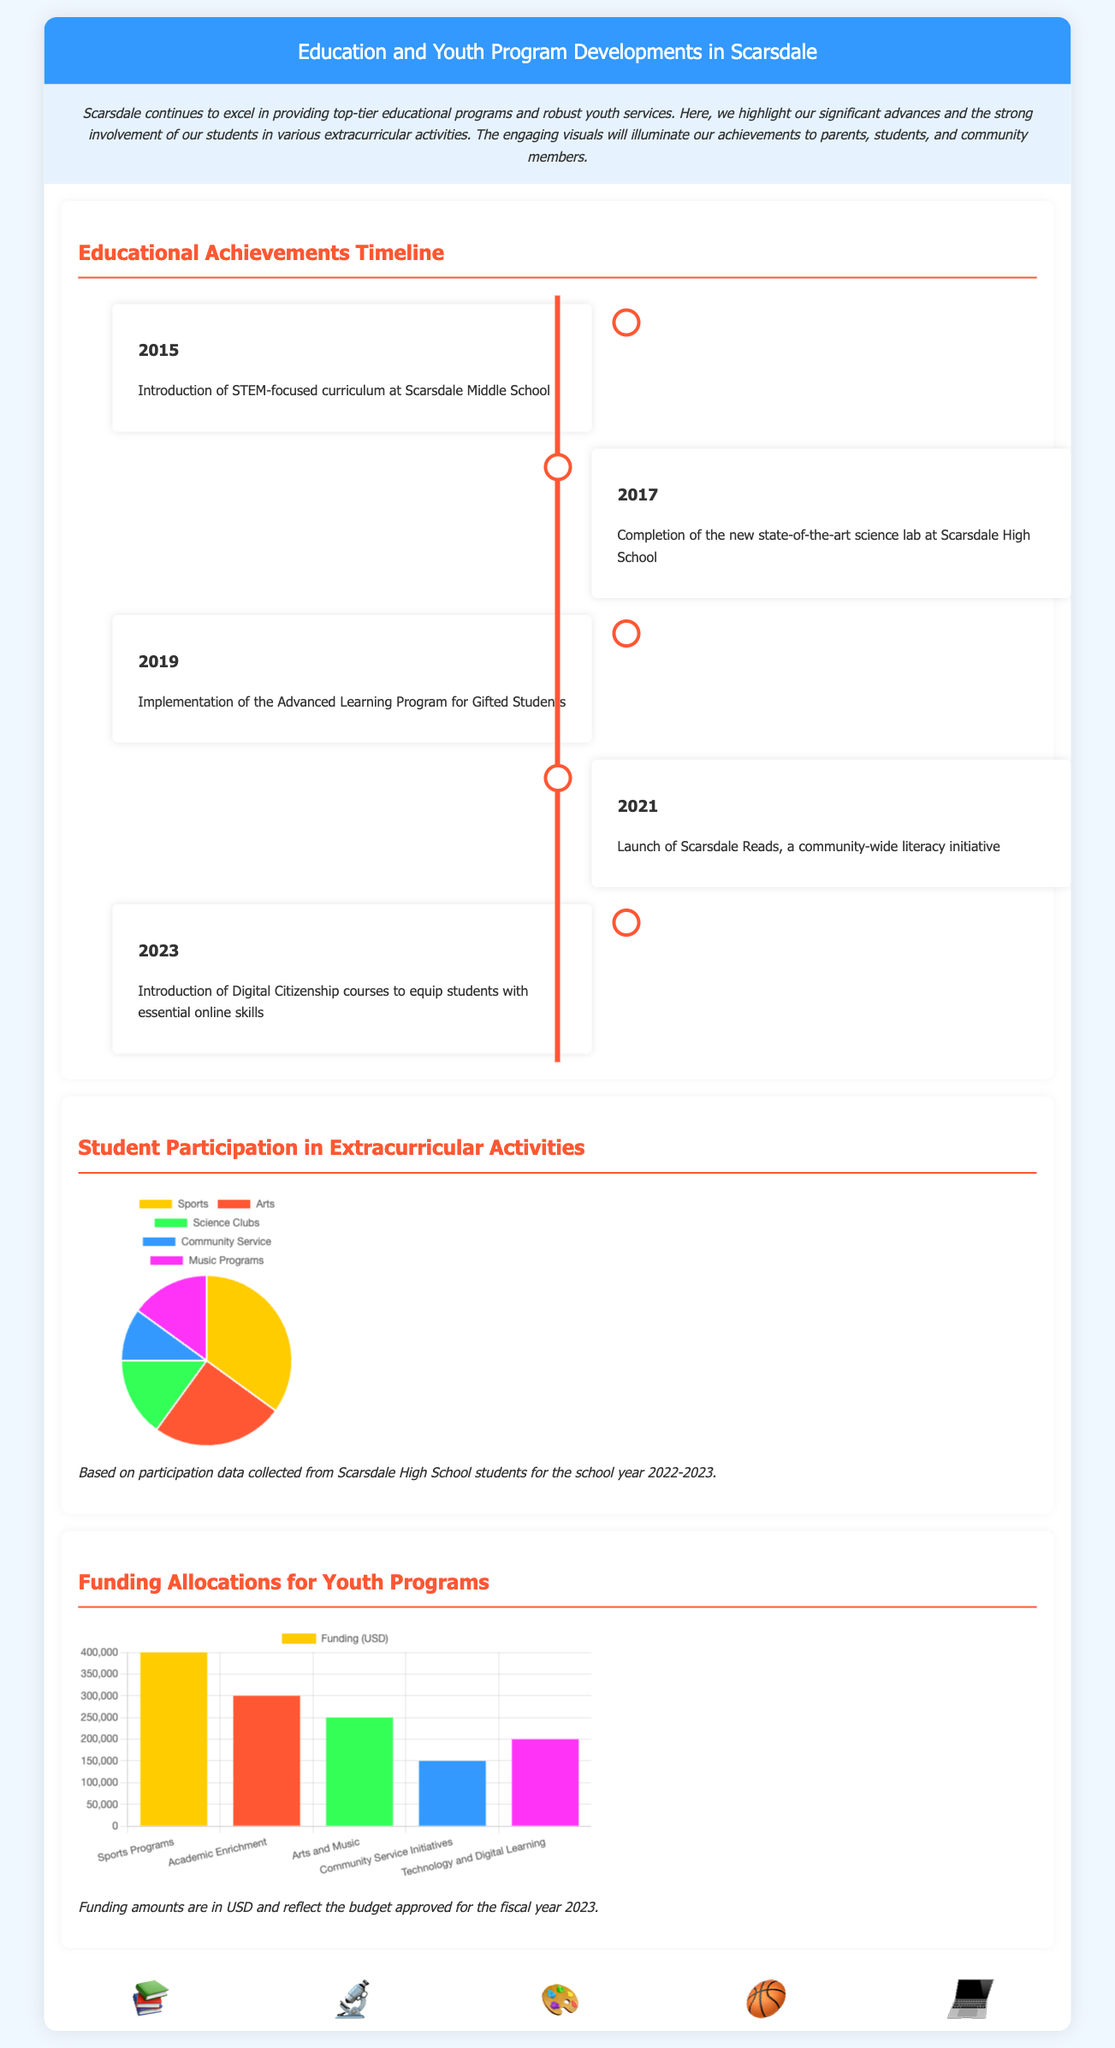What year was the STEM curriculum introduced? The document states that the STEM-focused curriculum was introduced at Scarsdale Middle School in 2015.
Answer: 2015 What percent of students participate in sports? According to the pie chart, 35% of students participate in sports.
Answer: 35% What was completed in 2017? The document mentions the completion of the new state-of-the-art science lab at Scarsdale High School in 2017.
Answer: Science lab How much funding is allocated for sports programs? The funding chart shows that $400,000 is allocated for sports programs.
Answer: $400,000 What is the title of the community-wide literacy initiative launched in 2021? The text in the timeline indicates that the initiative launched in 2021 is called Scarsdale Reads.
Answer: Scarsdale Reads Which activity has the lowest student participation? From the pie chart, community service has the lowest participation at 10%.
Answer: Community Service What is the total funding allocated for technology and digital learning? The funding chart displays the allocation of $200,000 for technology and digital learning programs.
Answer: $200,000 Which year saw the introduction of Digital Citizenship courses? The timeline indicates that Digital Citizenship courses were introduced in 2023.
Answer: 2023 What are the main areas of funding in the bar graph? The funding areas depicted in the bar graph are Sports Programs, Academic Enrichment, Arts and Music, Community Service Initiatives, and Technology.
Answer: Five areas 